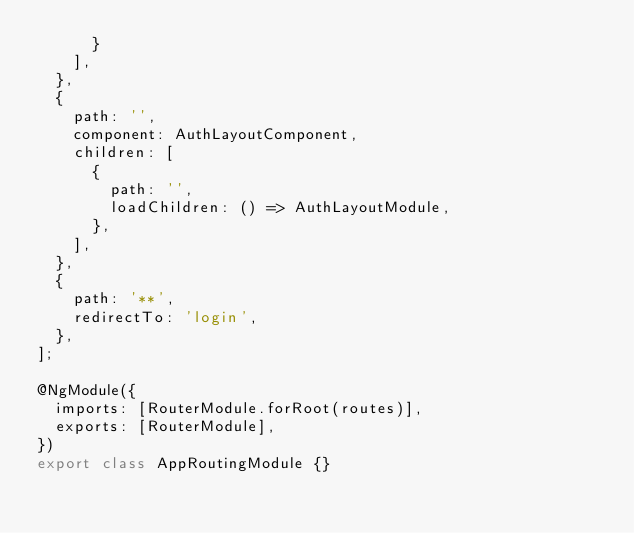<code> <loc_0><loc_0><loc_500><loc_500><_TypeScript_>      }
    ],
  },
  {
    path: '',
    component: AuthLayoutComponent,
    children: [
      {
        path: '',
        loadChildren: () => AuthLayoutModule,
      },
    ],
  },
  {
    path: '**',
    redirectTo: 'login',
  },
];

@NgModule({
  imports: [RouterModule.forRoot(routes)],
  exports: [RouterModule],
})
export class AppRoutingModule {}
</code> 